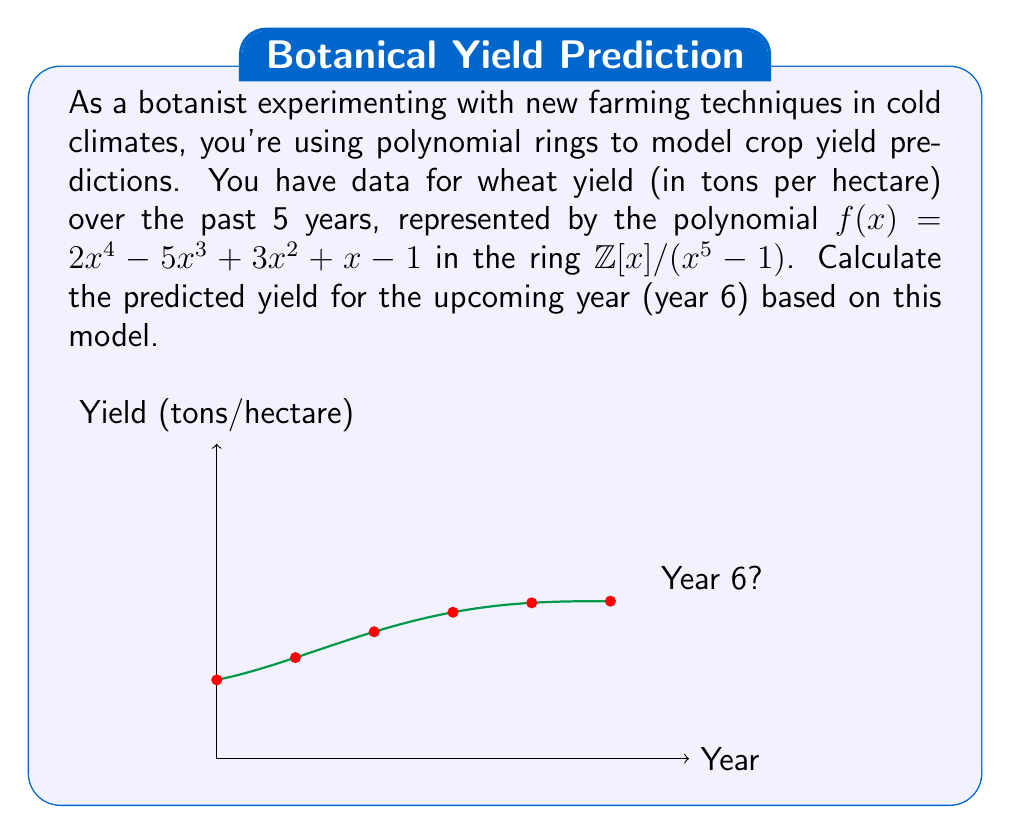Solve this math problem. To solve this problem, we need to understand how polynomial rings work in modular arithmetic:

1) In the ring $\mathbb{Z}[x]/(x^5 - 1)$, we have $x^5 \equiv 1 \pmod{x^5 - 1}$.

2) This means that for any polynomial in this ring, we can replace $x^5$ with 1, $x^6$ with $x$, $x^7$ with $x^2$, and so on.

3) To find the yield for year 6, we need to evaluate $f(6)$ in this ring.

4) $f(6) = 2(6^4) - 5(6^3) + 3(6^2) + 6 - 1$

5) In our ring:
   $6^4 \equiv 6^4 \pmod{x^5 - 1} \equiv 6 \cdot 6^3 \equiv 6 \cdot 1 \equiv 6$
   $6^3 \equiv 6^3 \pmod{x^5 - 1} \equiv 1$
   $6^2 \equiv 6^2 \pmod{x^5 - 1} \equiv 1$

6) Substituting these values:
   $f(6) = 2(6) - 5(1) + 3(1) + 6 - 1$

7) Calculating:
   $f(6) = 12 - 5 + 3 + 6 - 1 = 15$

Therefore, the predicted yield for year 6 is 15 tons per hectare.
Answer: 15 tons/hectare 